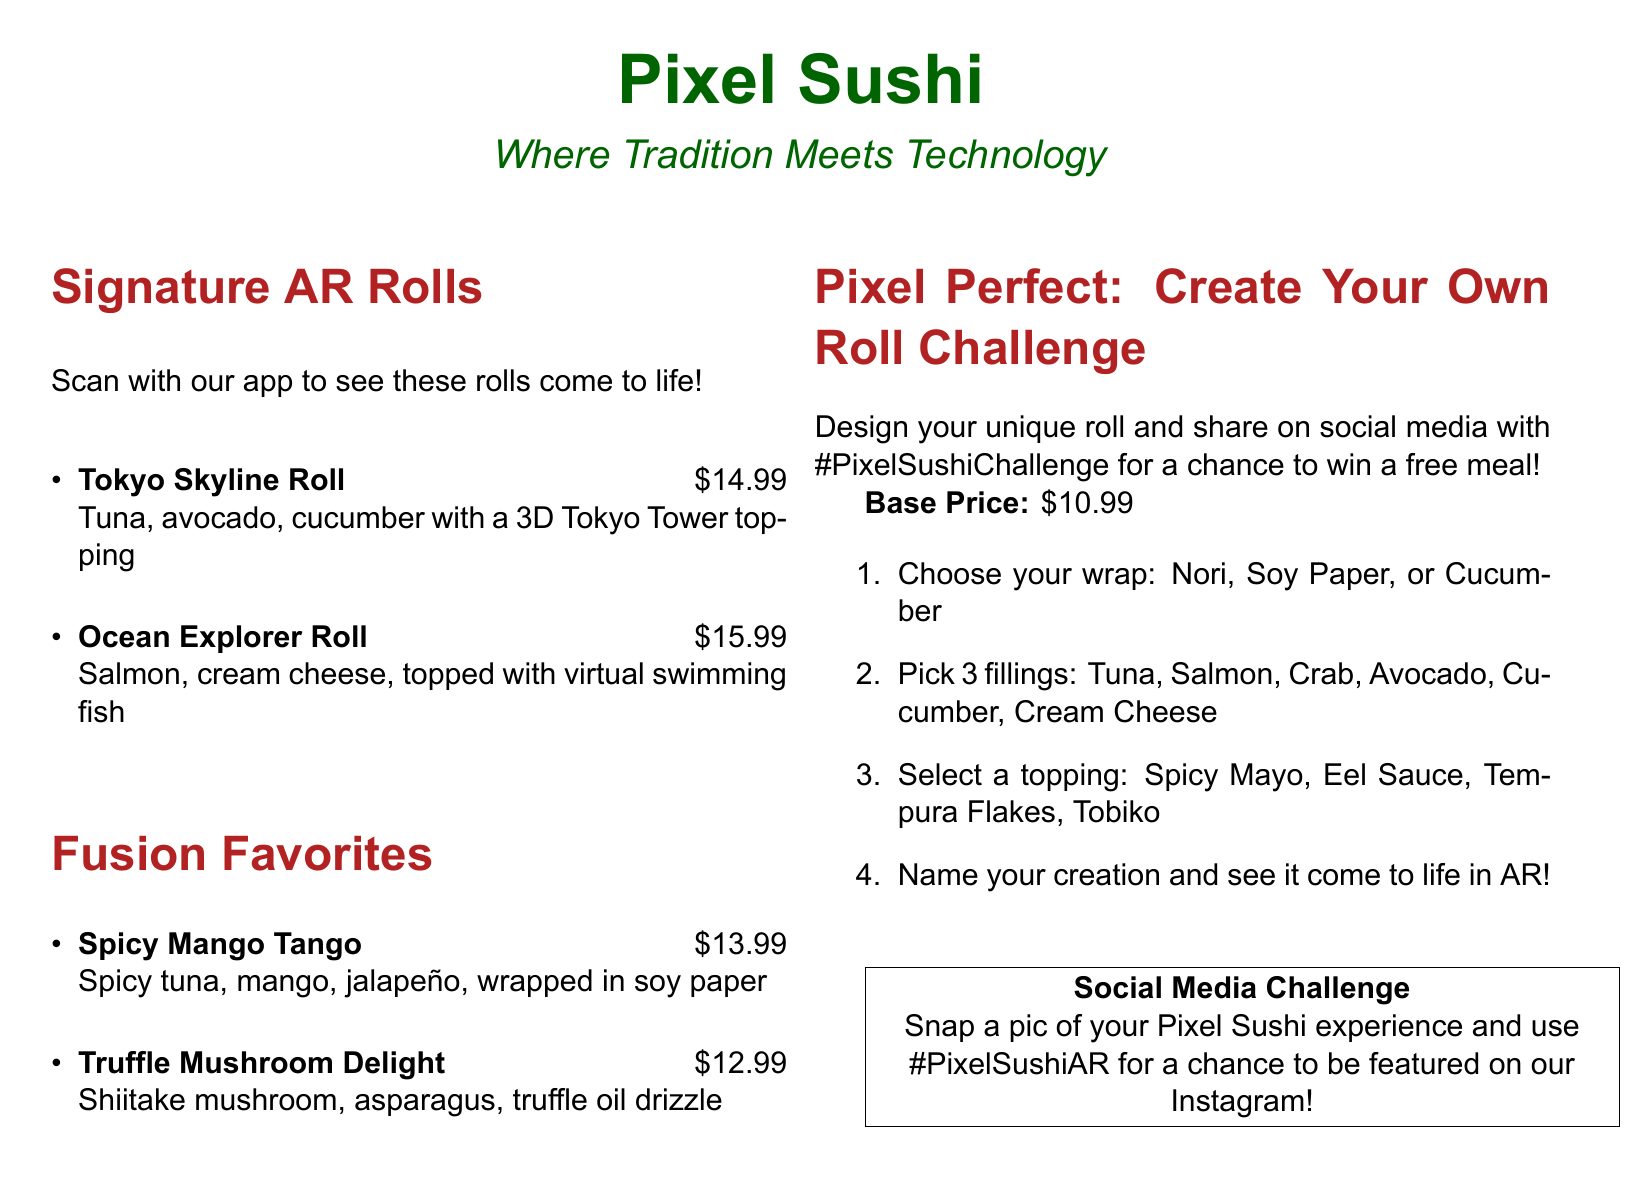What is the name of the restaurant? The name of the restaurant is prominently displayed at the top of the menu.
Answer: Pixel Sushi How many signature AR rolls are listed? The menu explicitly mentions the number of signature AR rolls in the section title.
Answer: 2 What is the price of the Ocean Explorer Roll? The price is listed next to the name of the roll in the document.
Answer: $15.99 What are the available wraps for the Create Your Own Roll challenge? The menu specifies the options for wraps in the challenge section.
Answer: Nori, Soy Paper, Cucumber How many fillings can be selected in the Create Your Own Roll challenge? The challenge outline states how many fillings you can choose.
Answer: 3 What is the base price of creating a custom roll? The base price is clearly mentioned in the Create Your Own Roll challenge section.
Answer: $10.99 What do participants need to include when sharing their creation on social media? The document specifies what to use when sharing your roll on social media.
Answer: #PixelSushiChallenge Which topping can you choose for the Create Your Own Roll? The available toppings are listed in the challenge description.
Answer: Spicy Mayo, Eel Sauce, Tempura Flakes, Tobiko What is the theme described under Pixel Sushi? The theme emphasizes the combination of culinary and technological elements.
Answer: Where Tradition Meets Technology 